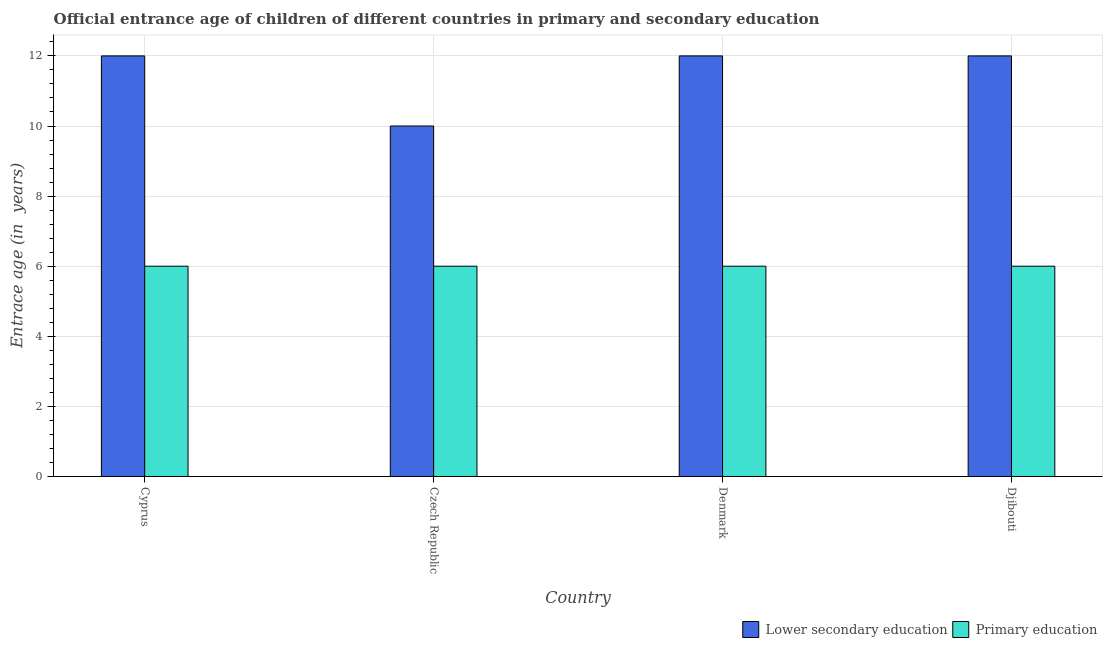Are the number of bars per tick equal to the number of legend labels?
Ensure brevity in your answer.  Yes. What is the label of the 4th group of bars from the left?
Your response must be concise. Djibouti. In how many cases, is the number of bars for a given country not equal to the number of legend labels?
Make the answer very short. 0. What is the entrance age of children in lower secondary education in Djibouti?
Give a very brief answer. 12. Across all countries, what is the maximum entrance age of children in lower secondary education?
Make the answer very short. 12. Across all countries, what is the minimum entrance age of chiildren in primary education?
Your response must be concise. 6. In which country was the entrance age of chiildren in primary education maximum?
Your response must be concise. Cyprus. In which country was the entrance age of chiildren in primary education minimum?
Your response must be concise. Cyprus. What is the total entrance age of children in lower secondary education in the graph?
Give a very brief answer. 46. What is the difference between the entrance age of children in lower secondary education in Cyprus and that in Czech Republic?
Make the answer very short. 2. What is the difference between the entrance age of chiildren in primary education in Djibouti and the entrance age of children in lower secondary education in Czech Republic?
Your answer should be very brief. -4. What is the average entrance age of chiildren in primary education per country?
Ensure brevity in your answer.  6. What is the difference between the entrance age of children in lower secondary education and entrance age of chiildren in primary education in Denmark?
Your answer should be compact. 6. In how many countries, is the entrance age of chiildren in primary education greater than 3.2 years?
Your answer should be very brief. 4. What is the ratio of the entrance age of children in lower secondary education in Czech Republic to that in Djibouti?
Make the answer very short. 0.83. In how many countries, is the entrance age of chiildren in primary education greater than the average entrance age of chiildren in primary education taken over all countries?
Offer a terse response. 0. What does the 1st bar from the right in Cyprus represents?
Your response must be concise. Primary education. How many bars are there?
Make the answer very short. 8. What is the difference between two consecutive major ticks on the Y-axis?
Provide a short and direct response. 2. Does the graph contain any zero values?
Ensure brevity in your answer.  No. Where does the legend appear in the graph?
Offer a very short reply. Bottom right. How many legend labels are there?
Your answer should be compact. 2. How are the legend labels stacked?
Offer a terse response. Horizontal. What is the title of the graph?
Give a very brief answer. Official entrance age of children of different countries in primary and secondary education. What is the label or title of the X-axis?
Keep it short and to the point. Country. What is the label or title of the Y-axis?
Provide a succinct answer. Entrace age (in  years). What is the Entrace age (in  years) in Primary education in Cyprus?
Ensure brevity in your answer.  6. What is the Entrace age (in  years) of Primary education in Czech Republic?
Provide a short and direct response. 6. What is the Entrace age (in  years) of Lower secondary education in Djibouti?
Give a very brief answer. 12. Across all countries, what is the maximum Entrace age (in  years) of Primary education?
Offer a terse response. 6. What is the difference between the Entrace age (in  years) of Primary education in Cyprus and that in Denmark?
Keep it short and to the point. 0. What is the difference between the Entrace age (in  years) of Lower secondary education in Czech Republic and that in Denmark?
Your answer should be compact. -2. What is the difference between the Entrace age (in  years) in Primary education in Czech Republic and that in Denmark?
Provide a succinct answer. 0. What is the difference between the Entrace age (in  years) of Primary education in Czech Republic and that in Djibouti?
Make the answer very short. 0. What is the difference between the Entrace age (in  years) in Lower secondary education in Cyprus and the Entrace age (in  years) in Primary education in Czech Republic?
Provide a succinct answer. 6. What is the average Entrace age (in  years) of Primary education per country?
Ensure brevity in your answer.  6. What is the ratio of the Entrace age (in  years) in Lower secondary education in Cyprus to that in Czech Republic?
Make the answer very short. 1.2. What is the ratio of the Entrace age (in  years) in Primary education in Cyprus to that in Czech Republic?
Offer a terse response. 1. What is the ratio of the Entrace age (in  years) in Lower secondary education in Cyprus to that in Denmark?
Your answer should be compact. 1. What is the ratio of the Entrace age (in  years) of Primary education in Cyprus to that in Denmark?
Offer a terse response. 1. What is the ratio of the Entrace age (in  years) of Primary education in Czech Republic to that in Denmark?
Offer a terse response. 1. What is the ratio of the Entrace age (in  years) in Lower secondary education in Czech Republic to that in Djibouti?
Make the answer very short. 0.83. What is the ratio of the Entrace age (in  years) in Primary education in Denmark to that in Djibouti?
Provide a short and direct response. 1. What is the difference between the highest and the second highest Entrace age (in  years) in Lower secondary education?
Offer a very short reply. 0. What is the difference between the highest and the second highest Entrace age (in  years) in Primary education?
Offer a very short reply. 0. What is the difference between the highest and the lowest Entrace age (in  years) of Lower secondary education?
Your response must be concise. 2. What is the difference between the highest and the lowest Entrace age (in  years) in Primary education?
Provide a succinct answer. 0. 